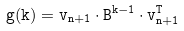Convert formula to latex. <formula><loc_0><loc_0><loc_500><loc_500>\tt g ( k ) = v _ { n + 1 } \cdot \tt B ^ { k - 1 } \cdot v ^ { T } _ { n + 1 }</formula> 